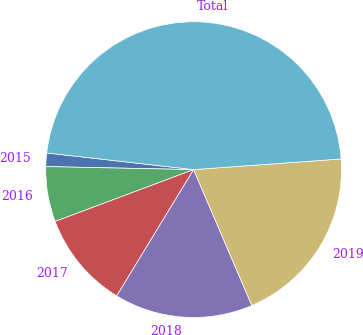Convert chart to OTSL. <chart><loc_0><loc_0><loc_500><loc_500><pie_chart><fcel>2015<fcel>2016<fcel>2017<fcel>2018<fcel>2019<fcel>Total<nl><fcel>1.47%<fcel>6.03%<fcel>10.59%<fcel>15.15%<fcel>19.71%<fcel>47.06%<nl></chart> 